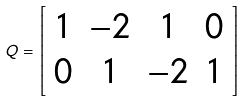<formula> <loc_0><loc_0><loc_500><loc_500>Q = \left [ \begin{array} { c c c c } 1 & - 2 & 1 & 0 \\ 0 & 1 & - 2 & 1 \end{array} \right ]</formula> 